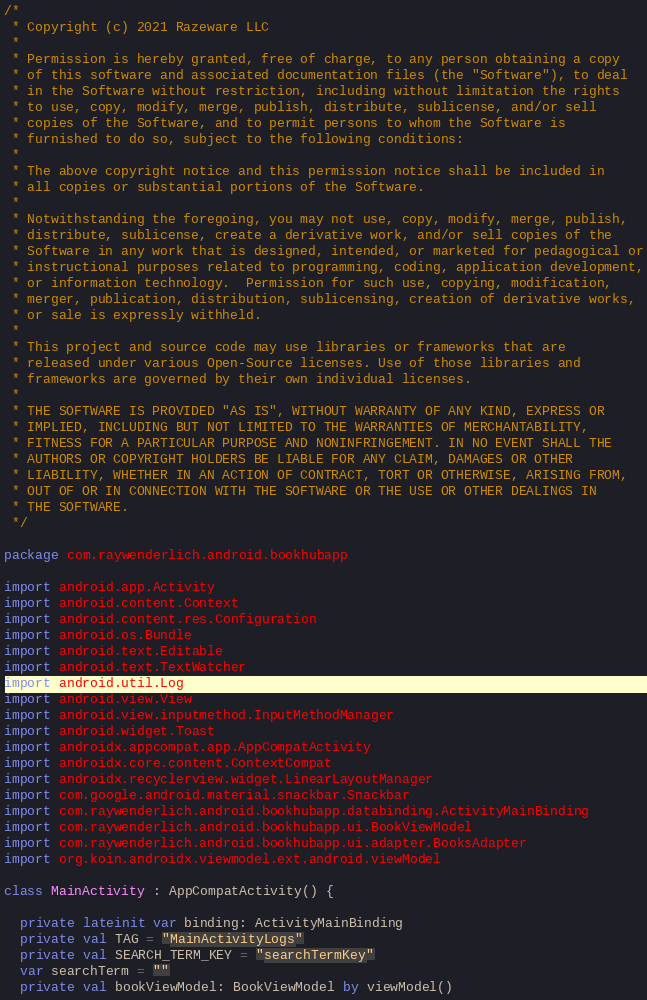Convert code to text. <code><loc_0><loc_0><loc_500><loc_500><_Kotlin_>/*
 * Copyright (c) 2021 Razeware LLC
 * 
 * Permission is hereby granted, free of charge, to any person obtaining a copy
 * of this software and associated documentation files (the "Software"), to deal
 * in the Software without restriction, including without limitation the rights
 * to use, copy, modify, merge, publish, distribute, sublicense, and/or sell
 * copies of the Software, and to permit persons to whom the Software is
 * furnished to do so, subject to the following conditions:
 * 
 * The above copyright notice and this permission notice shall be included in
 * all copies or substantial portions of the Software.
 * 
 * Notwithstanding the foregoing, you may not use, copy, modify, merge, publish,
 * distribute, sublicense, create a derivative work, and/or sell copies of the
 * Software in any work that is designed, intended, or marketed for pedagogical or
 * instructional purposes related to programming, coding, application development,
 * or information technology.  Permission for such use, copying, modification,
 * merger, publication, distribution, sublicensing, creation of derivative works,
 * or sale is expressly withheld.
 * 
 * This project and source code may use libraries or frameworks that are
 * released under various Open-Source licenses. Use of those libraries and
 * frameworks are governed by their own individual licenses.
 * 
 * THE SOFTWARE IS PROVIDED "AS IS", WITHOUT WARRANTY OF ANY KIND, EXPRESS OR
 * IMPLIED, INCLUDING BUT NOT LIMITED TO THE WARRANTIES OF MERCHANTABILITY,
 * FITNESS FOR A PARTICULAR PURPOSE AND NONINFRINGEMENT. IN NO EVENT SHALL THE
 * AUTHORS OR COPYRIGHT HOLDERS BE LIABLE FOR ANY CLAIM, DAMAGES OR OTHER
 * LIABILITY, WHETHER IN AN ACTION OF CONTRACT, TORT OR OTHERWISE, ARISING FROM,
 * OUT OF OR IN CONNECTION WITH THE SOFTWARE OR THE USE OR OTHER DEALINGS IN
 * THE SOFTWARE.
 */

package com.raywenderlich.android.bookhubapp

import android.app.Activity
import android.content.Context
import android.content.res.Configuration
import android.os.Bundle
import android.text.Editable
import android.text.TextWatcher
import android.util.Log
import android.view.View
import android.view.inputmethod.InputMethodManager
import android.widget.Toast
import androidx.appcompat.app.AppCompatActivity
import androidx.core.content.ContextCompat
import androidx.recyclerview.widget.LinearLayoutManager
import com.google.android.material.snackbar.Snackbar
import com.raywenderlich.android.bookhubapp.databinding.ActivityMainBinding
import com.raywenderlich.android.bookhubapp.ui.BookViewModel
import com.raywenderlich.android.bookhubapp.ui.adapter.BooksAdapter
import org.koin.androidx.viewmodel.ext.android.viewModel

class MainActivity : AppCompatActivity() {

  private lateinit var binding: ActivityMainBinding
  private val TAG = "MainActivityLogs"
  private val SEARCH_TERM_KEY = "searchTermKey"
  var searchTerm = ""
  private val bookViewModel: BookViewModel by viewModel()</code> 